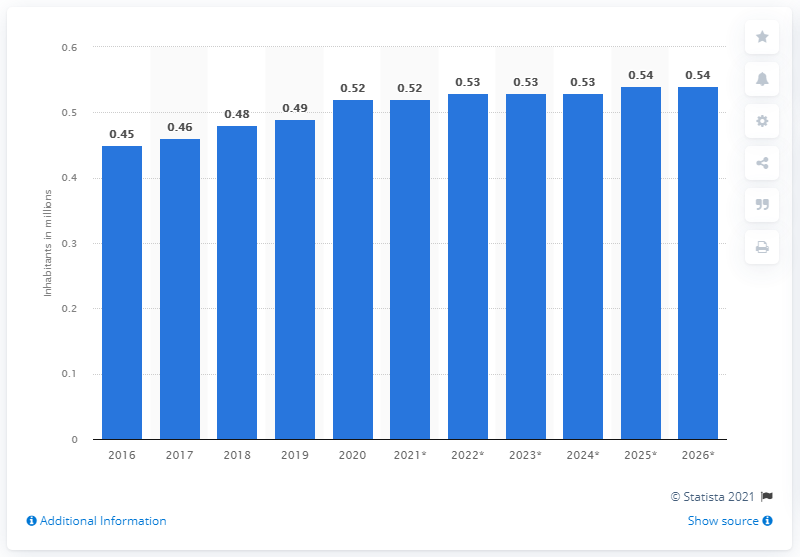Highlight a few significant elements in this photo. The population of Malta is expected to end in 2020. The population of Malta is believed to have ended in 2020. 